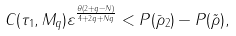<formula> <loc_0><loc_0><loc_500><loc_500>C ( \tau _ { 1 } , M _ { q } ) \varepsilon ^ { \frac { \theta ( 2 + q - N ) } { 4 + 2 q + N q } } < P ( \bar { \rho } _ { 2 } ) - P ( \tilde { \rho } ) ,</formula> 